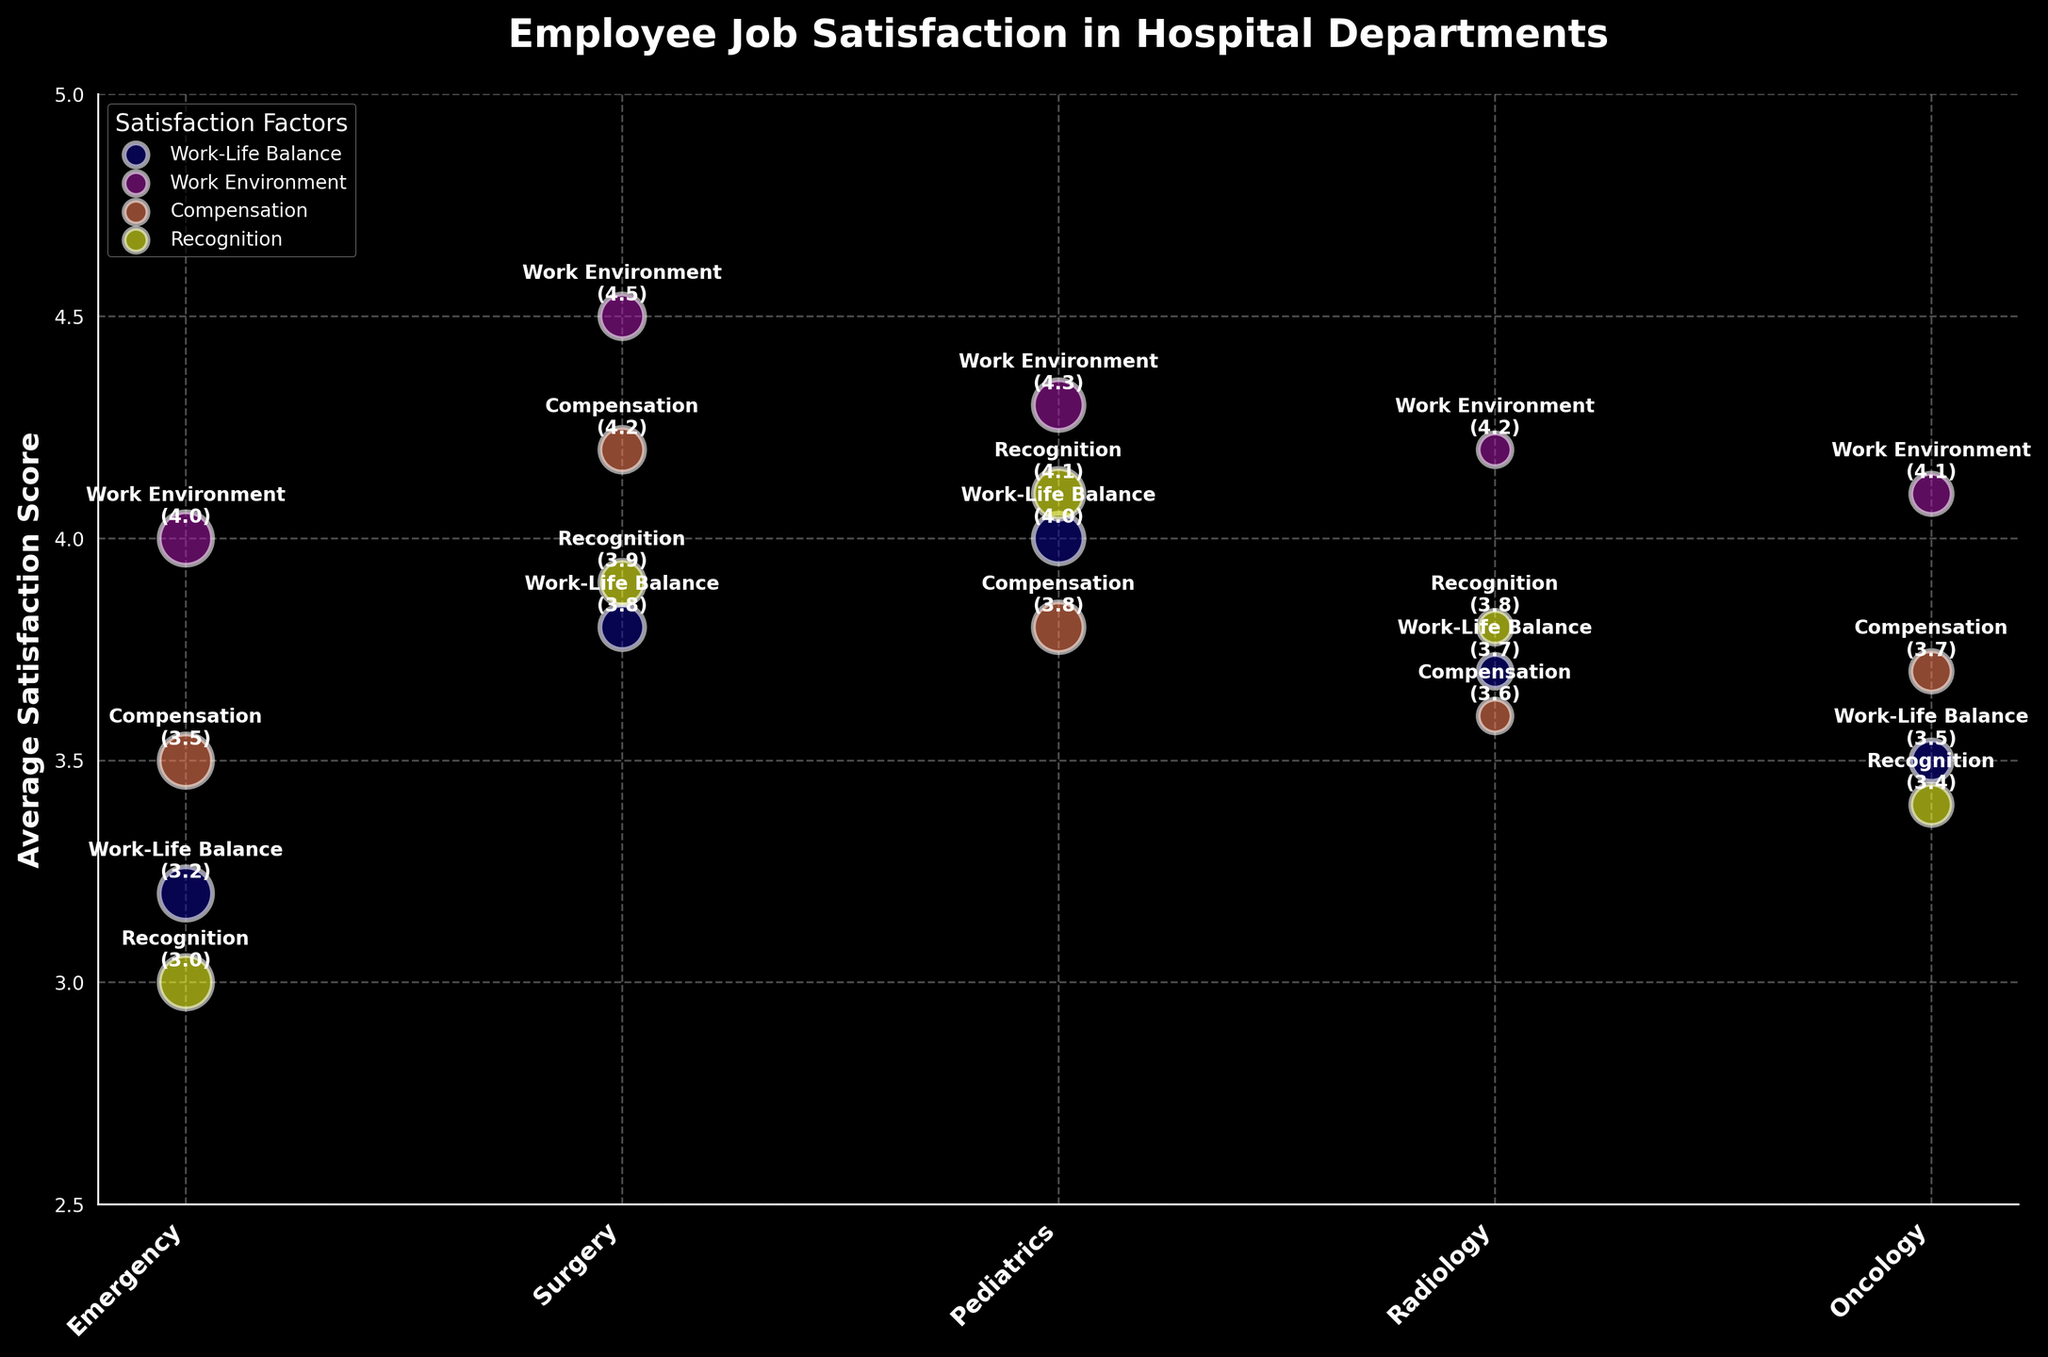Which department has the highest average satisfaction score for Work-Life Balance? Look at the 'Work-Life Balance' bubbles for each department. The Surgery department has the highest score of 4.0.
Answer: Surgery How many departments have an average satisfaction score higher than 4 for Work Environment? Count the bubbles representing 'Work Environment' with a score higher than 4. There are three departments: Surgery (4.5), Pediatrics (4.3), and Radiology (4.2).
Answer: 3 What is the average satisfaction score for Compensation across all departments? Sum up the average satisfaction scores for Compensation across all departments (3.5 + 4.2 + 3.8 + 3.6 + 3.7) and divide by the number of departments, which is 5. The calculation is (3.5 + 4.2 + 3.8 + 3.6 + 3.7) / 5 = 3.76.
Answer: 3.76 Which satisfaction factor appears highest on the y-axis for Pediatrics? Look at the placement of bubbles for each Satisfaction Factor in Pediatrics. The Recognition bubble (value 4.1) is the highest on the y-axis.
Answer: Recognition Which department has the smallest bubble size for Work-Life Balance? The department with the smallest bubble for Work-Life Balance is Radiology, as it has the fewest number of employees at 20.
Answer: Radiology 